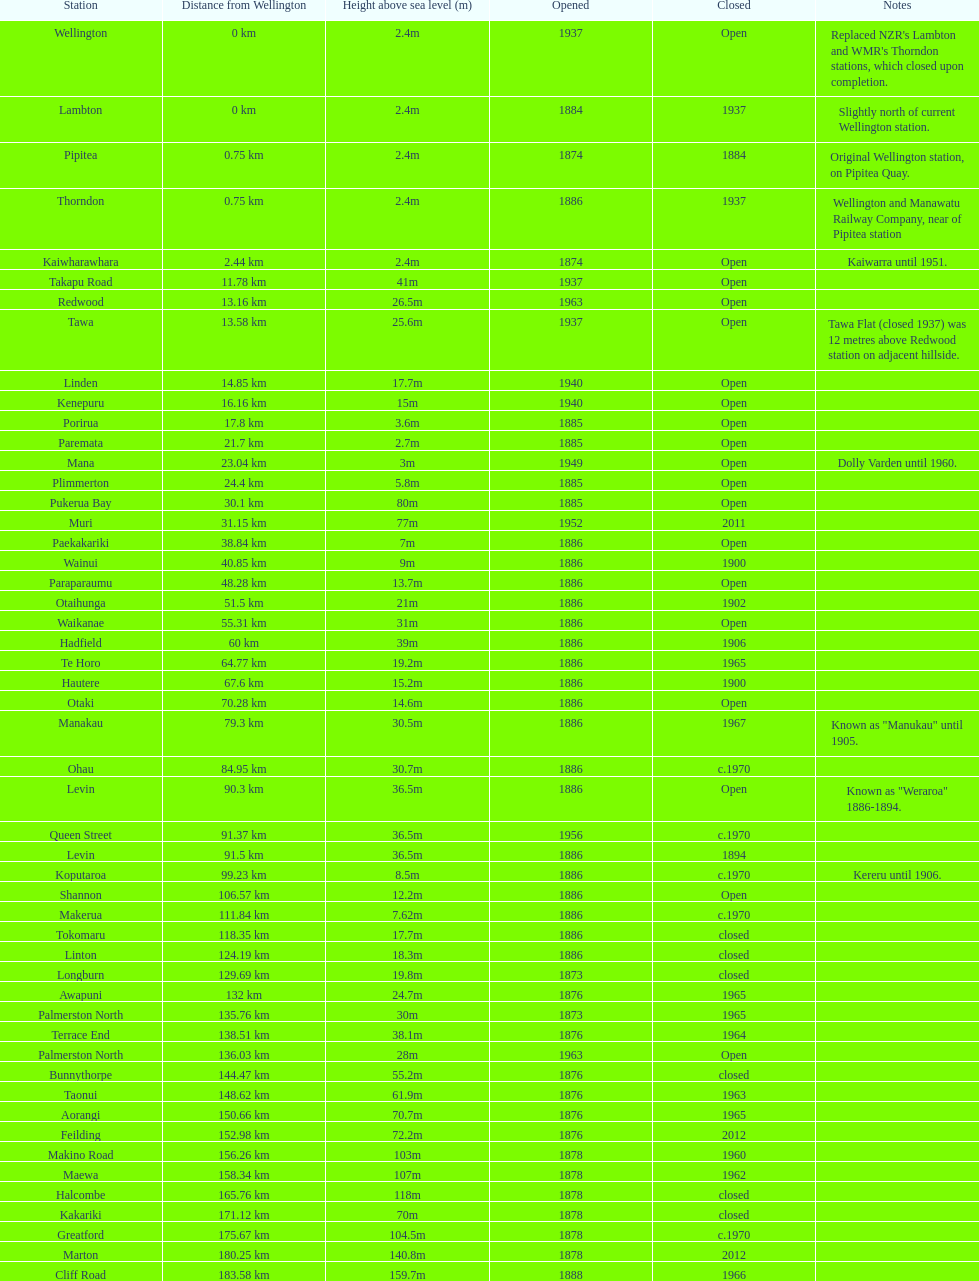What is the elevation difference between takapu road station and wellington station? 38.6m. 